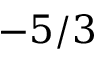<formula> <loc_0><loc_0><loc_500><loc_500>5 / 3</formula> 